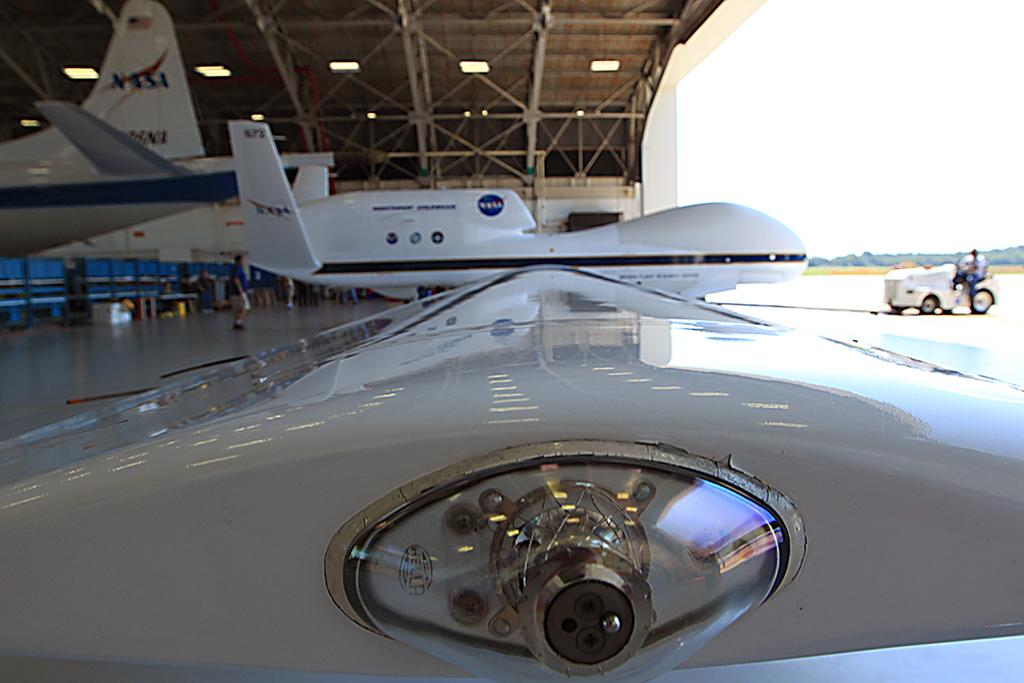Provide a one-sentence caption for the provided image. A hangar with several airplanes that are for NASA. 